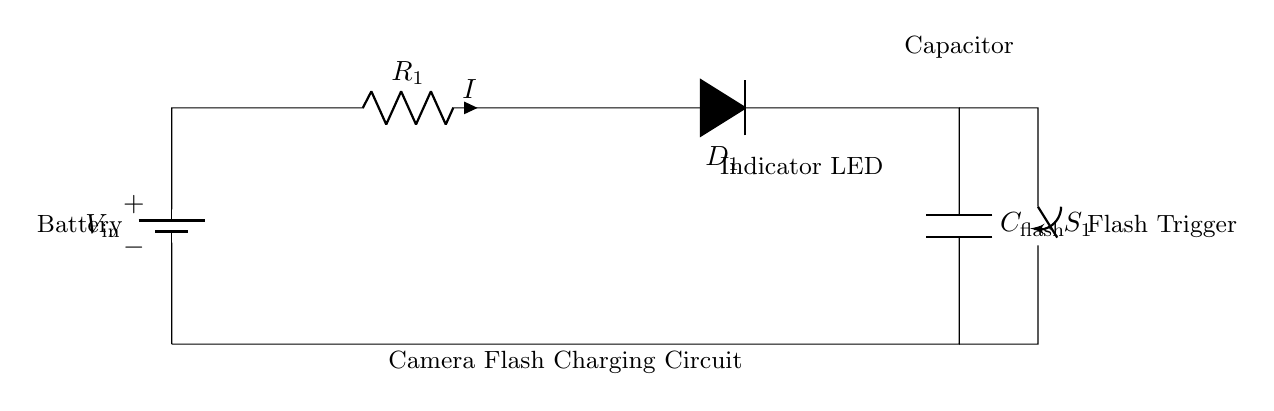What is the main function of this circuit? The main function of this circuit is to charge a capacitor for a camera flash, enabling the flash to discharge its stored energy when triggered.
Answer: charge a capacitor for a camera flash What type of switch is used in this circuit? The switch used in this circuit is a toggle switch, identified by the symbol marked as `S_1` in the diagram.
Answer: toggle switch What component is indicated by `D_1`? The component indicated by `D_1` is an LED, which serves as an indicator light to show that the circuit is energized.
Answer: LED What happens when switch `S_1` is closed? When switch `S_1` is closed, the circuit becomes complete, allowing current to flow and the capacitor `C_flash` to charge.
Answer: capacitor charges How is the current `I` flowing in this circuit defined? The current `I` flowing in the circuit is defined by Ohm's law, determined by the voltage input (`V_in`) divided by the resistance value (`R_1`).
Answer: defined by Ohm's law What is the role of the resistor `R_1` in this circuit? The role of the resistor `R_1` is to limit the amount of current flowing to prevent damage to the LED and manage the charging rate of the capacitor.
Answer: limit current 